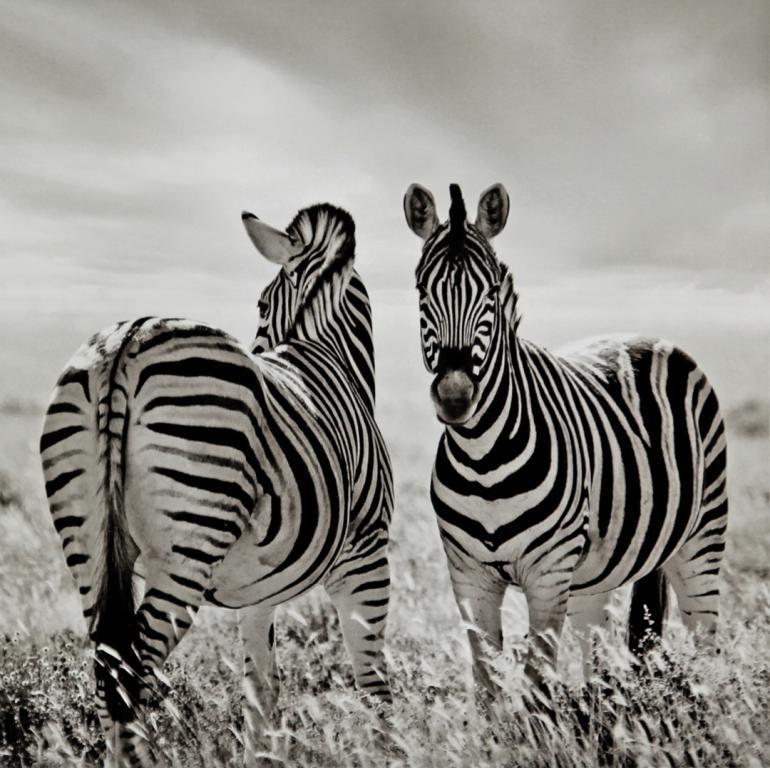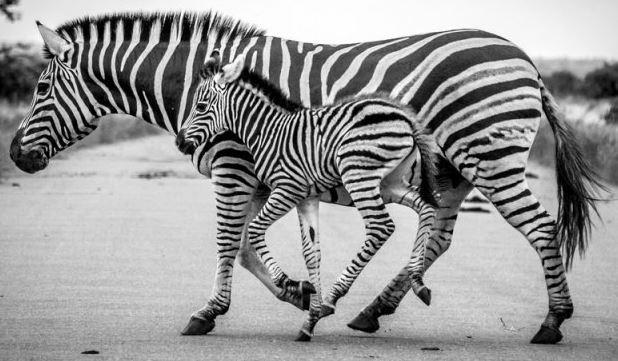The first image is the image on the left, the second image is the image on the right. Examine the images to the left and right. Is the description "Two standing zebras whose heads are parallel in height have their bodies turned toward each other in the right image." accurate? Answer yes or no. No. The first image is the image on the left, the second image is the image on the right. For the images displayed, is the sentence "Both images have the same number of zebras." factually correct? Answer yes or no. Yes. 